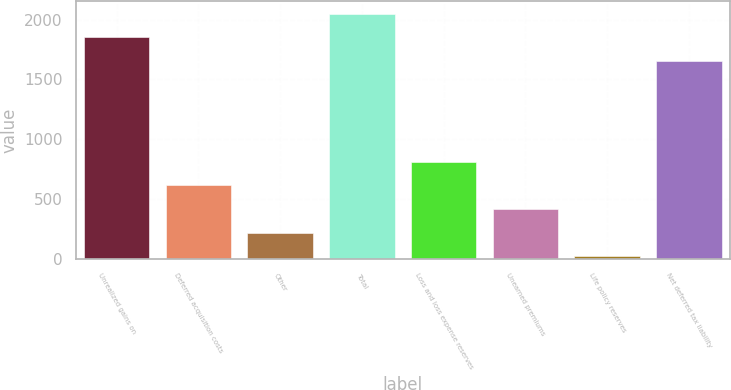Convert chart. <chart><loc_0><loc_0><loc_500><loc_500><bar_chart><fcel>Unrealized gains on<fcel>Deferred acquisition costs<fcel>Other<fcel>Total<fcel>Loss and loss expense reserves<fcel>Unearned premiums<fcel>Life policy reserves<fcel>Net deferred tax liability<nl><fcel>1851<fcel>616<fcel>220<fcel>2049<fcel>814<fcel>418<fcel>22<fcel>1653<nl></chart> 